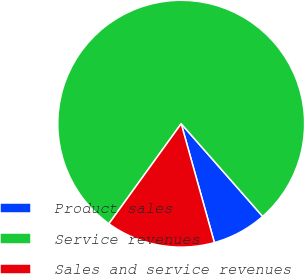Convert chart. <chart><loc_0><loc_0><loc_500><loc_500><pie_chart><fcel>Product sales<fcel>Service revenues<fcel>Sales and service revenues<nl><fcel>7.14%<fcel>78.57%<fcel>14.29%<nl></chart> 